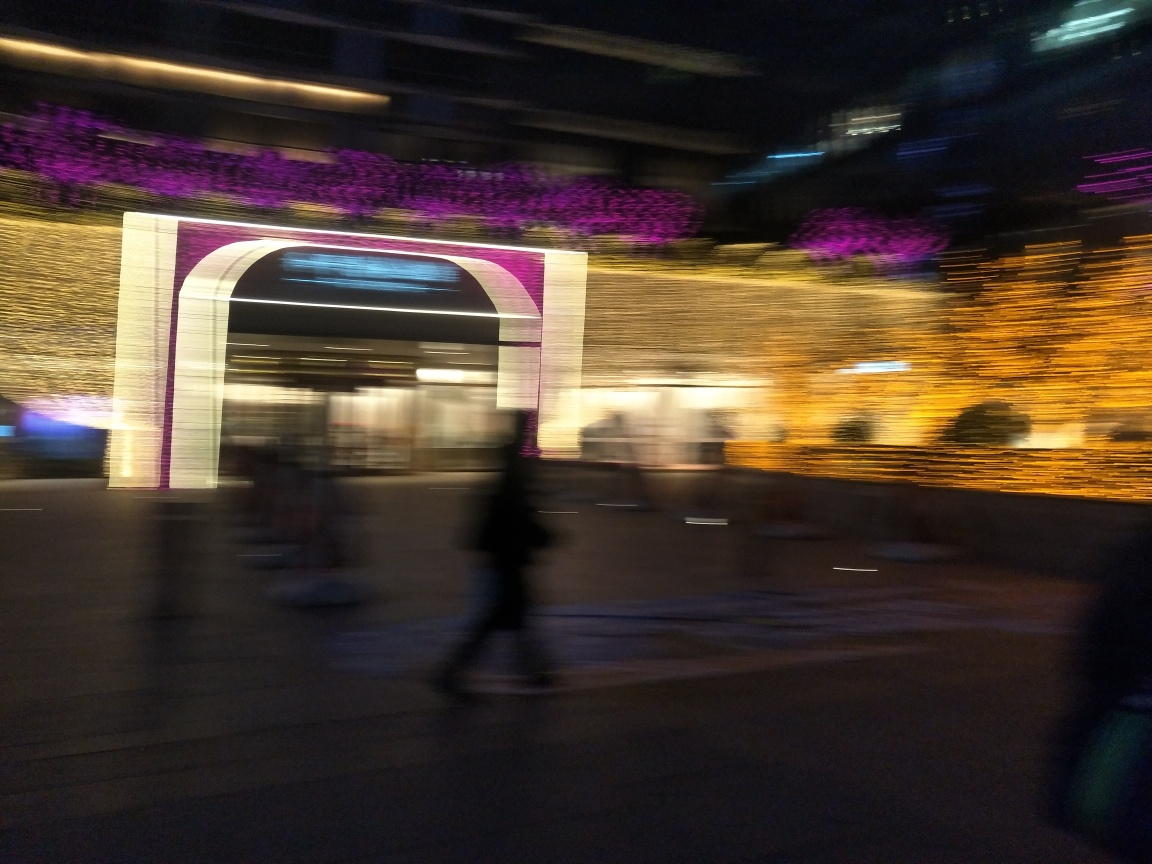Does the blurriness of the image affect the mood or atmosphere? The blurriness adds a sense of motion and liveliness to the image, creating a dynamic and somewhat ephemeral atmosphere that suggests activity and energy. 